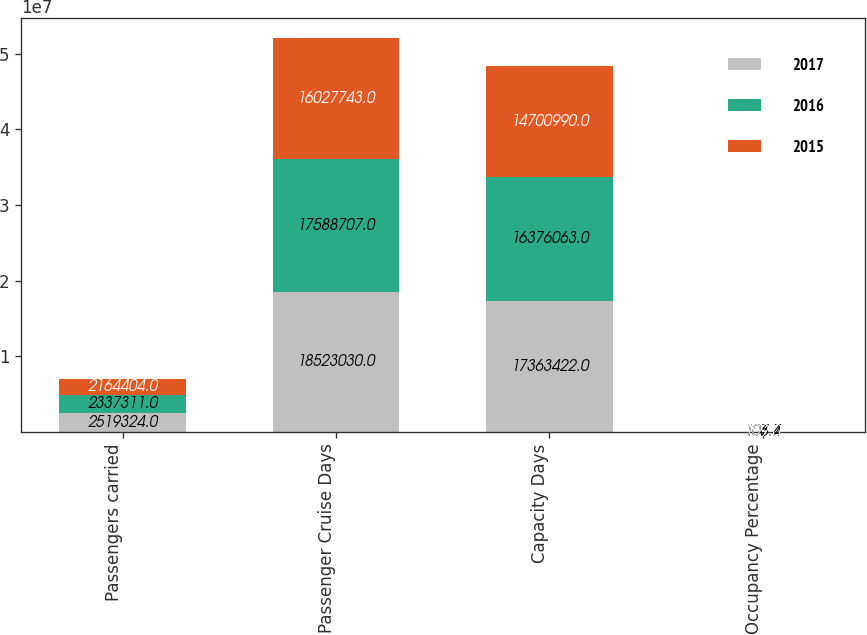<chart> <loc_0><loc_0><loc_500><loc_500><stacked_bar_chart><ecel><fcel>Passengers carried<fcel>Passenger Cruise Days<fcel>Capacity Days<fcel>Occupancy Percentage<nl><fcel>2017<fcel>2.51932e+06<fcel>1.8523e+07<fcel>1.73634e+07<fcel>106.7<nl><fcel>2016<fcel>2.33731e+06<fcel>1.75887e+07<fcel>1.63761e+07<fcel>107.4<nl><fcel>2015<fcel>2.1644e+06<fcel>1.60277e+07<fcel>1.4701e+07<fcel>109<nl></chart> 